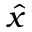Convert formula to latex. <formula><loc_0><loc_0><loc_500><loc_500>\hat { x }</formula> 